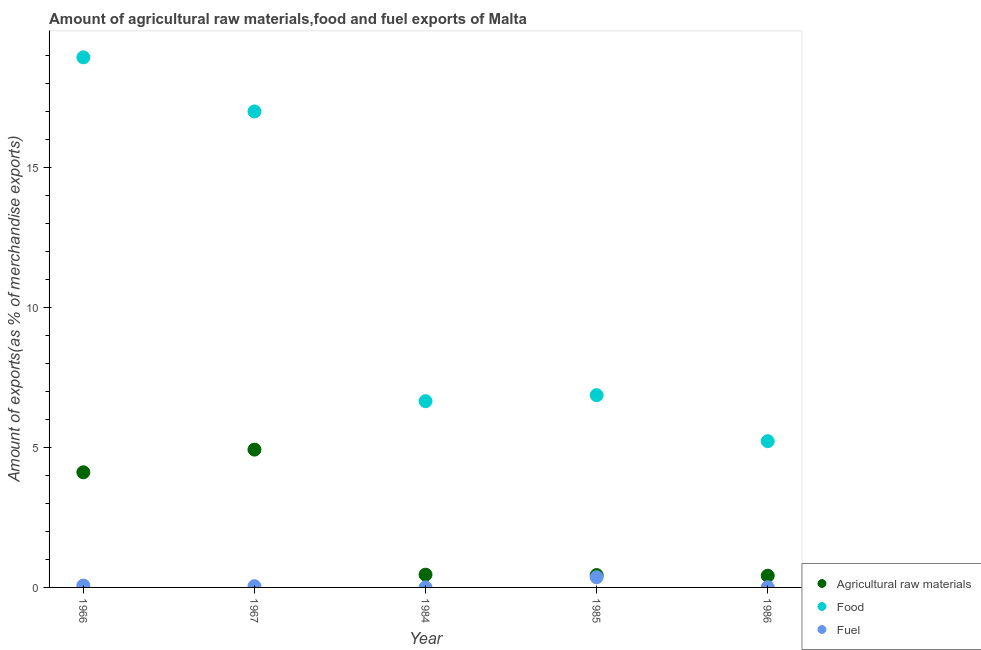How many different coloured dotlines are there?
Provide a succinct answer. 3. Is the number of dotlines equal to the number of legend labels?
Keep it short and to the point. Yes. What is the percentage of food exports in 1985?
Make the answer very short. 6.87. Across all years, what is the maximum percentage of fuel exports?
Provide a short and direct response. 0.36. Across all years, what is the minimum percentage of raw materials exports?
Your answer should be compact. 0.42. What is the total percentage of food exports in the graph?
Your response must be concise. 54.73. What is the difference between the percentage of food exports in 1967 and that in 1984?
Provide a short and direct response. 10.36. What is the difference between the percentage of fuel exports in 1966 and the percentage of food exports in 1967?
Provide a succinct answer. -16.95. What is the average percentage of fuel exports per year?
Provide a short and direct response. 0.1. In the year 1986, what is the difference between the percentage of fuel exports and percentage of food exports?
Your answer should be compact. -5.22. In how many years, is the percentage of raw materials exports greater than 17 %?
Ensure brevity in your answer.  0. What is the ratio of the percentage of food exports in 1966 to that in 1985?
Your answer should be very brief. 2.76. Is the percentage of raw materials exports in 1966 less than that in 1984?
Provide a succinct answer. No. What is the difference between the highest and the second highest percentage of fuel exports?
Give a very brief answer. 0.3. What is the difference between the highest and the lowest percentage of fuel exports?
Provide a succinct answer. 0.36. Is the sum of the percentage of raw materials exports in 1966 and 1986 greater than the maximum percentage of food exports across all years?
Provide a short and direct response. No. Is the percentage of raw materials exports strictly less than the percentage of food exports over the years?
Offer a very short reply. Yes. How many dotlines are there?
Your answer should be compact. 3. What is the difference between two consecutive major ticks on the Y-axis?
Make the answer very short. 5. Are the values on the major ticks of Y-axis written in scientific E-notation?
Keep it short and to the point. No. Does the graph contain any zero values?
Ensure brevity in your answer.  No. Does the graph contain grids?
Provide a short and direct response. No. Where does the legend appear in the graph?
Offer a very short reply. Bottom right. How many legend labels are there?
Your answer should be compact. 3. What is the title of the graph?
Give a very brief answer. Amount of agricultural raw materials,food and fuel exports of Malta. What is the label or title of the X-axis?
Provide a short and direct response. Year. What is the label or title of the Y-axis?
Offer a terse response. Amount of exports(as % of merchandise exports). What is the Amount of exports(as % of merchandise exports) in Agricultural raw materials in 1966?
Provide a short and direct response. 4.12. What is the Amount of exports(as % of merchandise exports) of Food in 1966?
Provide a succinct answer. 18.95. What is the Amount of exports(as % of merchandise exports) in Fuel in 1966?
Provide a succinct answer. 0.07. What is the Amount of exports(as % of merchandise exports) of Agricultural raw materials in 1967?
Provide a short and direct response. 4.93. What is the Amount of exports(as % of merchandise exports) of Food in 1967?
Provide a succinct answer. 17.02. What is the Amount of exports(as % of merchandise exports) of Fuel in 1967?
Your response must be concise. 0.04. What is the Amount of exports(as % of merchandise exports) in Agricultural raw materials in 1984?
Offer a very short reply. 0.46. What is the Amount of exports(as % of merchandise exports) of Food in 1984?
Make the answer very short. 6.66. What is the Amount of exports(as % of merchandise exports) in Fuel in 1984?
Your response must be concise. 0. What is the Amount of exports(as % of merchandise exports) in Agricultural raw materials in 1985?
Offer a terse response. 0.44. What is the Amount of exports(as % of merchandise exports) of Food in 1985?
Make the answer very short. 6.87. What is the Amount of exports(as % of merchandise exports) of Fuel in 1985?
Your answer should be compact. 0.36. What is the Amount of exports(as % of merchandise exports) of Agricultural raw materials in 1986?
Your answer should be very brief. 0.42. What is the Amount of exports(as % of merchandise exports) in Food in 1986?
Give a very brief answer. 5.23. What is the Amount of exports(as % of merchandise exports) in Fuel in 1986?
Provide a succinct answer. 0.01. Across all years, what is the maximum Amount of exports(as % of merchandise exports) in Agricultural raw materials?
Offer a very short reply. 4.93. Across all years, what is the maximum Amount of exports(as % of merchandise exports) in Food?
Ensure brevity in your answer.  18.95. Across all years, what is the maximum Amount of exports(as % of merchandise exports) in Fuel?
Provide a short and direct response. 0.36. Across all years, what is the minimum Amount of exports(as % of merchandise exports) of Agricultural raw materials?
Offer a very short reply. 0.42. Across all years, what is the minimum Amount of exports(as % of merchandise exports) of Food?
Provide a short and direct response. 5.23. Across all years, what is the minimum Amount of exports(as % of merchandise exports) of Fuel?
Provide a succinct answer. 0. What is the total Amount of exports(as % of merchandise exports) in Agricultural raw materials in the graph?
Ensure brevity in your answer.  10.36. What is the total Amount of exports(as % of merchandise exports) of Food in the graph?
Make the answer very short. 54.73. What is the total Amount of exports(as % of merchandise exports) of Fuel in the graph?
Provide a short and direct response. 0.48. What is the difference between the Amount of exports(as % of merchandise exports) of Agricultural raw materials in 1966 and that in 1967?
Give a very brief answer. -0.81. What is the difference between the Amount of exports(as % of merchandise exports) of Food in 1966 and that in 1967?
Keep it short and to the point. 1.93. What is the difference between the Amount of exports(as % of merchandise exports) of Fuel in 1966 and that in 1967?
Make the answer very short. 0.02. What is the difference between the Amount of exports(as % of merchandise exports) of Agricultural raw materials in 1966 and that in 1984?
Provide a short and direct response. 3.66. What is the difference between the Amount of exports(as % of merchandise exports) in Food in 1966 and that in 1984?
Provide a succinct answer. 12.29. What is the difference between the Amount of exports(as % of merchandise exports) in Fuel in 1966 and that in 1984?
Offer a very short reply. 0.07. What is the difference between the Amount of exports(as % of merchandise exports) in Agricultural raw materials in 1966 and that in 1985?
Offer a terse response. 3.67. What is the difference between the Amount of exports(as % of merchandise exports) of Food in 1966 and that in 1985?
Keep it short and to the point. 12.08. What is the difference between the Amount of exports(as % of merchandise exports) of Fuel in 1966 and that in 1985?
Your answer should be very brief. -0.3. What is the difference between the Amount of exports(as % of merchandise exports) of Agricultural raw materials in 1966 and that in 1986?
Provide a short and direct response. 3.7. What is the difference between the Amount of exports(as % of merchandise exports) in Food in 1966 and that in 1986?
Make the answer very short. 13.72. What is the difference between the Amount of exports(as % of merchandise exports) of Fuel in 1966 and that in 1986?
Offer a terse response. 0.06. What is the difference between the Amount of exports(as % of merchandise exports) in Agricultural raw materials in 1967 and that in 1984?
Give a very brief answer. 4.47. What is the difference between the Amount of exports(as % of merchandise exports) of Food in 1967 and that in 1984?
Give a very brief answer. 10.36. What is the difference between the Amount of exports(as % of merchandise exports) in Fuel in 1967 and that in 1984?
Offer a terse response. 0.04. What is the difference between the Amount of exports(as % of merchandise exports) of Agricultural raw materials in 1967 and that in 1985?
Keep it short and to the point. 4.48. What is the difference between the Amount of exports(as % of merchandise exports) in Food in 1967 and that in 1985?
Offer a very short reply. 10.14. What is the difference between the Amount of exports(as % of merchandise exports) in Fuel in 1967 and that in 1985?
Keep it short and to the point. -0.32. What is the difference between the Amount of exports(as % of merchandise exports) of Agricultural raw materials in 1967 and that in 1986?
Your answer should be very brief. 4.51. What is the difference between the Amount of exports(as % of merchandise exports) of Food in 1967 and that in 1986?
Provide a short and direct response. 11.79. What is the difference between the Amount of exports(as % of merchandise exports) of Fuel in 1967 and that in 1986?
Your answer should be compact. 0.04. What is the difference between the Amount of exports(as % of merchandise exports) of Agricultural raw materials in 1984 and that in 1985?
Keep it short and to the point. 0.01. What is the difference between the Amount of exports(as % of merchandise exports) in Food in 1984 and that in 1985?
Ensure brevity in your answer.  -0.21. What is the difference between the Amount of exports(as % of merchandise exports) in Fuel in 1984 and that in 1985?
Your answer should be compact. -0.36. What is the difference between the Amount of exports(as % of merchandise exports) in Agricultural raw materials in 1984 and that in 1986?
Give a very brief answer. 0.04. What is the difference between the Amount of exports(as % of merchandise exports) in Food in 1984 and that in 1986?
Offer a very short reply. 1.43. What is the difference between the Amount of exports(as % of merchandise exports) in Fuel in 1984 and that in 1986?
Your answer should be very brief. -0.01. What is the difference between the Amount of exports(as % of merchandise exports) of Agricultural raw materials in 1985 and that in 1986?
Make the answer very short. 0.02. What is the difference between the Amount of exports(as % of merchandise exports) in Food in 1985 and that in 1986?
Keep it short and to the point. 1.64. What is the difference between the Amount of exports(as % of merchandise exports) in Fuel in 1985 and that in 1986?
Provide a succinct answer. 0.36. What is the difference between the Amount of exports(as % of merchandise exports) in Agricultural raw materials in 1966 and the Amount of exports(as % of merchandise exports) in Food in 1967?
Ensure brevity in your answer.  -12.9. What is the difference between the Amount of exports(as % of merchandise exports) of Agricultural raw materials in 1966 and the Amount of exports(as % of merchandise exports) of Fuel in 1967?
Your answer should be very brief. 4.07. What is the difference between the Amount of exports(as % of merchandise exports) of Food in 1966 and the Amount of exports(as % of merchandise exports) of Fuel in 1967?
Ensure brevity in your answer.  18.91. What is the difference between the Amount of exports(as % of merchandise exports) in Agricultural raw materials in 1966 and the Amount of exports(as % of merchandise exports) in Food in 1984?
Your response must be concise. -2.54. What is the difference between the Amount of exports(as % of merchandise exports) of Agricultural raw materials in 1966 and the Amount of exports(as % of merchandise exports) of Fuel in 1984?
Give a very brief answer. 4.12. What is the difference between the Amount of exports(as % of merchandise exports) of Food in 1966 and the Amount of exports(as % of merchandise exports) of Fuel in 1984?
Ensure brevity in your answer.  18.95. What is the difference between the Amount of exports(as % of merchandise exports) in Agricultural raw materials in 1966 and the Amount of exports(as % of merchandise exports) in Food in 1985?
Offer a terse response. -2.76. What is the difference between the Amount of exports(as % of merchandise exports) in Agricultural raw materials in 1966 and the Amount of exports(as % of merchandise exports) in Fuel in 1985?
Make the answer very short. 3.75. What is the difference between the Amount of exports(as % of merchandise exports) of Food in 1966 and the Amount of exports(as % of merchandise exports) of Fuel in 1985?
Give a very brief answer. 18.59. What is the difference between the Amount of exports(as % of merchandise exports) of Agricultural raw materials in 1966 and the Amount of exports(as % of merchandise exports) of Food in 1986?
Your answer should be compact. -1.11. What is the difference between the Amount of exports(as % of merchandise exports) of Agricultural raw materials in 1966 and the Amount of exports(as % of merchandise exports) of Fuel in 1986?
Ensure brevity in your answer.  4.11. What is the difference between the Amount of exports(as % of merchandise exports) in Food in 1966 and the Amount of exports(as % of merchandise exports) in Fuel in 1986?
Keep it short and to the point. 18.94. What is the difference between the Amount of exports(as % of merchandise exports) of Agricultural raw materials in 1967 and the Amount of exports(as % of merchandise exports) of Food in 1984?
Keep it short and to the point. -1.73. What is the difference between the Amount of exports(as % of merchandise exports) in Agricultural raw materials in 1967 and the Amount of exports(as % of merchandise exports) in Fuel in 1984?
Provide a short and direct response. 4.93. What is the difference between the Amount of exports(as % of merchandise exports) in Food in 1967 and the Amount of exports(as % of merchandise exports) in Fuel in 1984?
Provide a succinct answer. 17.02. What is the difference between the Amount of exports(as % of merchandise exports) of Agricultural raw materials in 1967 and the Amount of exports(as % of merchandise exports) of Food in 1985?
Your answer should be compact. -1.95. What is the difference between the Amount of exports(as % of merchandise exports) of Agricultural raw materials in 1967 and the Amount of exports(as % of merchandise exports) of Fuel in 1985?
Offer a terse response. 4.56. What is the difference between the Amount of exports(as % of merchandise exports) of Food in 1967 and the Amount of exports(as % of merchandise exports) of Fuel in 1985?
Ensure brevity in your answer.  16.65. What is the difference between the Amount of exports(as % of merchandise exports) of Agricultural raw materials in 1967 and the Amount of exports(as % of merchandise exports) of Food in 1986?
Your answer should be very brief. -0.3. What is the difference between the Amount of exports(as % of merchandise exports) of Agricultural raw materials in 1967 and the Amount of exports(as % of merchandise exports) of Fuel in 1986?
Give a very brief answer. 4.92. What is the difference between the Amount of exports(as % of merchandise exports) of Food in 1967 and the Amount of exports(as % of merchandise exports) of Fuel in 1986?
Keep it short and to the point. 17.01. What is the difference between the Amount of exports(as % of merchandise exports) of Agricultural raw materials in 1984 and the Amount of exports(as % of merchandise exports) of Food in 1985?
Keep it short and to the point. -6.42. What is the difference between the Amount of exports(as % of merchandise exports) of Agricultural raw materials in 1984 and the Amount of exports(as % of merchandise exports) of Fuel in 1985?
Your response must be concise. 0.09. What is the difference between the Amount of exports(as % of merchandise exports) of Food in 1984 and the Amount of exports(as % of merchandise exports) of Fuel in 1985?
Your answer should be compact. 6.29. What is the difference between the Amount of exports(as % of merchandise exports) in Agricultural raw materials in 1984 and the Amount of exports(as % of merchandise exports) in Food in 1986?
Give a very brief answer. -4.77. What is the difference between the Amount of exports(as % of merchandise exports) in Agricultural raw materials in 1984 and the Amount of exports(as % of merchandise exports) in Fuel in 1986?
Provide a short and direct response. 0.45. What is the difference between the Amount of exports(as % of merchandise exports) in Food in 1984 and the Amount of exports(as % of merchandise exports) in Fuel in 1986?
Keep it short and to the point. 6.65. What is the difference between the Amount of exports(as % of merchandise exports) of Agricultural raw materials in 1985 and the Amount of exports(as % of merchandise exports) of Food in 1986?
Your answer should be compact. -4.79. What is the difference between the Amount of exports(as % of merchandise exports) in Agricultural raw materials in 1985 and the Amount of exports(as % of merchandise exports) in Fuel in 1986?
Provide a short and direct response. 0.43. What is the difference between the Amount of exports(as % of merchandise exports) of Food in 1985 and the Amount of exports(as % of merchandise exports) of Fuel in 1986?
Make the answer very short. 6.86. What is the average Amount of exports(as % of merchandise exports) of Agricultural raw materials per year?
Keep it short and to the point. 2.07. What is the average Amount of exports(as % of merchandise exports) in Food per year?
Give a very brief answer. 10.95. What is the average Amount of exports(as % of merchandise exports) of Fuel per year?
Ensure brevity in your answer.  0.1. In the year 1966, what is the difference between the Amount of exports(as % of merchandise exports) of Agricultural raw materials and Amount of exports(as % of merchandise exports) of Food?
Your response must be concise. -14.83. In the year 1966, what is the difference between the Amount of exports(as % of merchandise exports) in Agricultural raw materials and Amount of exports(as % of merchandise exports) in Fuel?
Provide a succinct answer. 4.05. In the year 1966, what is the difference between the Amount of exports(as % of merchandise exports) of Food and Amount of exports(as % of merchandise exports) of Fuel?
Offer a terse response. 18.88. In the year 1967, what is the difference between the Amount of exports(as % of merchandise exports) in Agricultural raw materials and Amount of exports(as % of merchandise exports) in Food?
Give a very brief answer. -12.09. In the year 1967, what is the difference between the Amount of exports(as % of merchandise exports) in Agricultural raw materials and Amount of exports(as % of merchandise exports) in Fuel?
Provide a succinct answer. 4.88. In the year 1967, what is the difference between the Amount of exports(as % of merchandise exports) in Food and Amount of exports(as % of merchandise exports) in Fuel?
Offer a very short reply. 16.97. In the year 1984, what is the difference between the Amount of exports(as % of merchandise exports) of Agricultural raw materials and Amount of exports(as % of merchandise exports) of Food?
Your answer should be very brief. -6.2. In the year 1984, what is the difference between the Amount of exports(as % of merchandise exports) of Agricultural raw materials and Amount of exports(as % of merchandise exports) of Fuel?
Ensure brevity in your answer.  0.45. In the year 1984, what is the difference between the Amount of exports(as % of merchandise exports) in Food and Amount of exports(as % of merchandise exports) in Fuel?
Offer a terse response. 6.66. In the year 1985, what is the difference between the Amount of exports(as % of merchandise exports) in Agricultural raw materials and Amount of exports(as % of merchandise exports) in Food?
Provide a short and direct response. -6.43. In the year 1985, what is the difference between the Amount of exports(as % of merchandise exports) in Agricultural raw materials and Amount of exports(as % of merchandise exports) in Fuel?
Your answer should be very brief. 0.08. In the year 1985, what is the difference between the Amount of exports(as % of merchandise exports) of Food and Amount of exports(as % of merchandise exports) of Fuel?
Ensure brevity in your answer.  6.51. In the year 1986, what is the difference between the Amount of exports(as % of merchandise exports) of Agricultural raw materials and Amount of exports(as % of merchandise exports) of Food?
Your response must be concise. -4.81. In the year 1986, what is the difference between the Amount of exports(as % of merchandise exports) in Agricultural raw materials and Amount of exports(as % of merchandise exports) in Fuel?
Offer a terse response. 0.41. In the year 1986, what is the difference between the Amount of exports(as % of merchandise exports) of Food and Amount of exports(as % of merchandise exports) of Fuel?
Ensure brevity in your answer.  5.22. What is the ratio of the Amount of exports(as % of merchandise exports) in Agricultural raw materials in 1966 to that in 1967?
Provide a short and direct response. 0.84. What is the ratio of the Amount of exports(as % of merchandise exports) in Food in 1966 to that in 1967?
Make the answer very short. 1.11. What is the ratio of the Amount of exports(as % of merchandise exports) of Fuel in 1966 to that in 1967?
Give a very brief answer. 1.5. What is the ratio of the Amount of exports(as % of merchandise exports) in Agricultural raw materials in 1966 to that in 1984?
Provide a succinct answer. 9.04. What is the ratio of the Amount of exports(as % of merchandise exports) of Food in 1966 to that in 1984?
Give a very brief answer. 2.85. What is the ratio of the Amount of exports(as % of merchandise exports) in Fuel in 1966 to that in 1984?
Your answer should be compact. 157.64. What is the ratio of the Amount of exports(as % of merchandise exports) in Agricultural raw materials in 1966 to that in 1985?
Your answer should be compact. 9.31. What is the ratio of the Amount of exports(as % of merchandise exports) of Food in 1966 to that in 1985?
Your answer should be very brief. 2.76. What is the ratio of the Amount of exports(as % of merchandise exports) in Fuel in 1966 to that in 1985?
Your answer should be very brief. 0.18. What is the ratio of the Amount of exports(as % of merchandise exports) of Agricultural raw materials in 1966 to that in 1986?
Your response must be concise. 9.83. What is the ratio of the Amount of exports(as % of merchandise exports) in Food in 1966 to that in 1986?
Your answer should be very brief. 3.62. What is the ratio of the Amount of exports(as % of merchandise exports) in Fuel in 1966 to that in 1986?
Your response must be concise. 7.55. What is the ratio of the Amount of exports(as % of merchandise exports) in Agricultural raw materials in 1967 to that in 1984?
Ensure brevity in your answer.  10.82. What is the ratio of the Amount of exports(as % of merchandise exports) in Food in 1967 to that in 1984?
Offer a very short reply. 2.56. What is the ratio of the Amount of exports(as % of merchandise exports) of Fuel in 1967 to that in 1984?
Provide a short and direct response. 105.3. What is the ratio of the Amount of exports(as % of merchandise exports) in Agricultural raw materials in 1967 to that in 1985?
Offer a terse response. 11.15. What is the ratio of the Amount of exports(as % of merchandise exports) in Food in 1967 to that in 1985?
Your response must be concise. 2.48. What is the ratio of the Amount of exports(as % of merchandise exports) of Fuel in 1967 to that in 1985?
Give a very brief answer. 0.12. What is the ratio of the Amount of exports(as % of merchandise exports) in Agricultural raw materials in 1967 to that in 1986?
Offer a terse response. 11.77. What is the ratio of the Amount of exports(as % of merchandise exports) of Food in 1967 to that in 1986?
Keep it short and to the point. 3.25. What is the ratio of the Amount of exports(as % of merchandise exports) in Fuel in 1967 to that in 1986?
Make the answer very short. 5.04. What is the ratio of the Amount of exports(as % of merchandise exports) in Agricultural raw materials in 1984 to that in 1985?
Offer a terse response. 1.03. What is the ratio of the Amount of exports(as % of merchandise exports) of Food in 1984 to that in 1985?
Keep it short and to the point. 0.97. What is the ratio of the Amount of exports(as % of merchandise exports) in Fuel in 1984 to that in 1985?
Make the answer very short. 0. What is the ratio of the Amount of exports(as % of merchandise exports) of Agricultural raw materials in 1984 to that in 1986?
Your response must be concise. 1.09. What is the ratio of the Amount of exports(as % of merchandise exports) of Food in 1984 to that in 1986?
Provide a short and direct response. 1.27. What is the ratio of the Amount of exports(as % of merchandise exports) of Fuel in 1984 to that in 1986?
Your answer should be compact. 0.05. What is the ratio of the Amount of exports(as % of merchandise exports) in Agricultural raw materials in 1985 to that in 1986?
Your answer should be compact. 1.06. What is the ratio of the Amount of exports(as % of merchandise exports) in Food in 1985 to that in 1986?
Your response must be concise. 1.31. What is the ratio of the Amount of exports(as % of merchandise exports) in Fuel in 1985 to that in 1986?
Your answer should be very brief. 41.05. What is the difference between the highest and the second highest Amount of exports(as % of merchandise exports) in Agricultural raw materials?
Offer a very short reply. 0.81. What is the difference between the highest and the second highest Amount of exports(as % of merchandise exports) of Food?
Make the answer very short. 1.93. What is the difference between the highest and the second highest Amount of exports(as % of merchandise exports) in Fuel?
Give a very brief answer. 0.3. What is the difference between the highest and the lowest Amount of exports(as % of merchandise exports) of Agricultural raw materials?
Give a very brief answer. 4.51. What is the difference between the highest and the lowest Amount of exports(as % of merchandise exports) of Food?
Offer a very short reply. 13.72. What is the difference between the highest and the lowest Amount of exports(as % of merchandise exports) of Fuel?
Your answer should be compact. 0.36. 